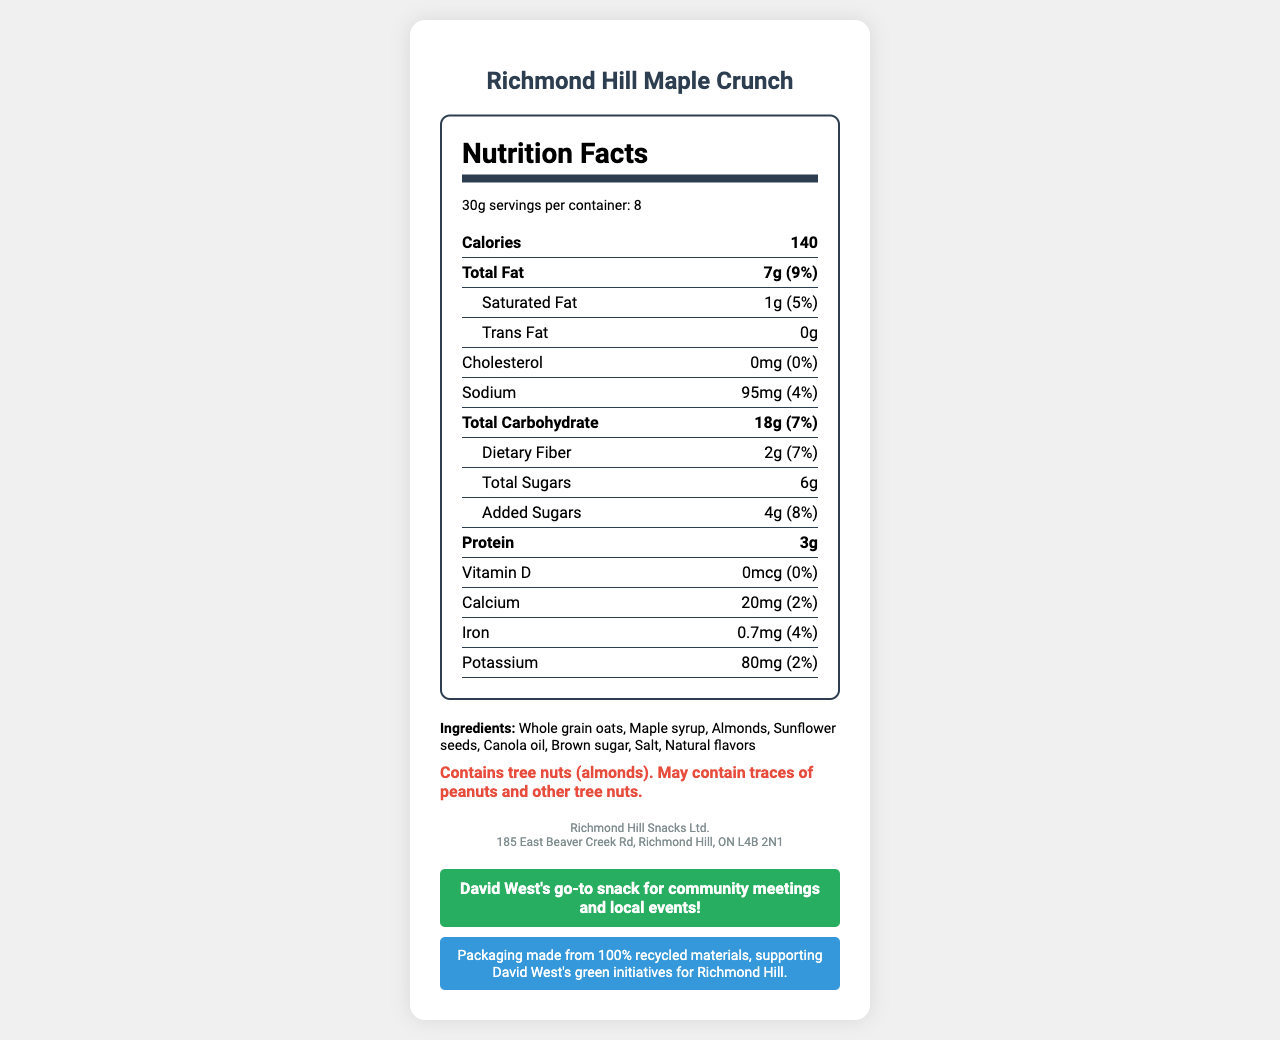what is the serving size of Richmond Hill Maple Crunch? The serving size of Richmond Hill Maple Crunch is mentioned at the top of the Nutrition Facts, which is 30g.
Answer: 30g how many calories are in one serving? The calories per serving are listed under the bold "Calories" heading, which states 140.
Answer: 140 how much protein is in the snack per serving? The document lists protein content directly under the bold "Protein" heading, indicating it contains 3g per serving.
Answer: 3g What is the total fat content in one serving? The total fat content is indicated under "Total Fat" in the document, which states 7g per serving.
Answer: 7g What is the daily value percentage of dietary fiber in one serving? The daily value percentage of dietary fiber is shown in the sub-section of "Total Carbohydrate," which indicates it is 7%.
Answer: 7% Which ingredient is not included in Richmond Hill Maple Crunch? A. Almonds B. Sugar C. Wheat The ingredients are listed in the document and include whole grain oats, maple syrup, almonds, sunflower seeds, canola oil, brown sugar, salt, and natural flavors. Wheat is not listed among them.
Answer: C. Wheat What is the sodium content per serving? The sodium content is listed under the "Sodium" heading, which shows 95mg per serving.
Answer: 95mg How many servings are in one container? The servings per container are indicated in the serving information, which states there are 8 servings per container.
Answer: 8 Is this snack endorsed by David West for community meetings and local events? The document includes a section with David West's endorsement, stating it is his go-to snack for community meetings and local events.
Answer: Yes What is the address of the manufacturer? The manufacturer's address is listed under the manufacturer section, which states 185 East Beaver Creek Rd, Richmond Hill, ON L4B 2N1.
Answer: 185 East Beaver Creek Rd, Richmond Hill, ON L4B 2N1 Which nutrient has the highest daily value percentage per serving? A. Cholesterol B. Iron C. Total Fat The daily value percentages are indicated in the document, with Total Fat having the highest at 9%.
Answer: C. Total Fat Does Richmond Hill Maple Crunch contain any Vitamin D? The document indicates the Vitamin D content as 0mcg, which means it contains no Vitamin D.
Answer: No What does the sustainability note mention about the packaging? The sustainability note in the document states that the packaging is made from 100% recycled materials, supporting David West's green initiatives for Richmond Hill.
Answer: It mentions that the packaging is made from 100% recycled materials. Summarize the nutrition information and additional notes for Richmond Hill Maple Crunch. Richmond Hill Maple Crunch is a local snack with detailed nutritional information, including calorie count, fat content, and other nutrients. It features natural ingredients and adheres to sustainable packaging practices. It is endorsed by David West for community gatherings, highlighting its local significance.
Answer: Richmond Hill Maple Crunch has a serving size of 30g, with 8 servings per container. Each serving contains 140 calories, 7g of total fat, 1g of saturated fat, 0g trans fat, 0mg cholesterol, 95mg sodium, 18g total carbohydrates, 2g dietary fiber, 6g total sugars including 4g added sugars, and 3g protein. It provides no Vitamin D, 2% of daily calcium, 4% of daily iron, and 2% daily potassium. Ingredients are whole grain oats, maple syrup, almonds, sunflower seeds, canola oil, brown sugar, salt, and natural flavors. There's a sustainability note about packaging made from 100% recycled materials, aligning with David West's green initiatives. David West endorses this as his go-to snack for community meetings and local events. What is the amount of added sugars in Richmond Hill Maple Crunch? The added sugars per serving are listed under the sub-section of "Total Carbohydrate," showing 4g added sugars.
Answer: 4g Does the product contain any artificial flavors? The document does not specify whether "natural flavors" includes any artificial components.
Answer: Not enough information 